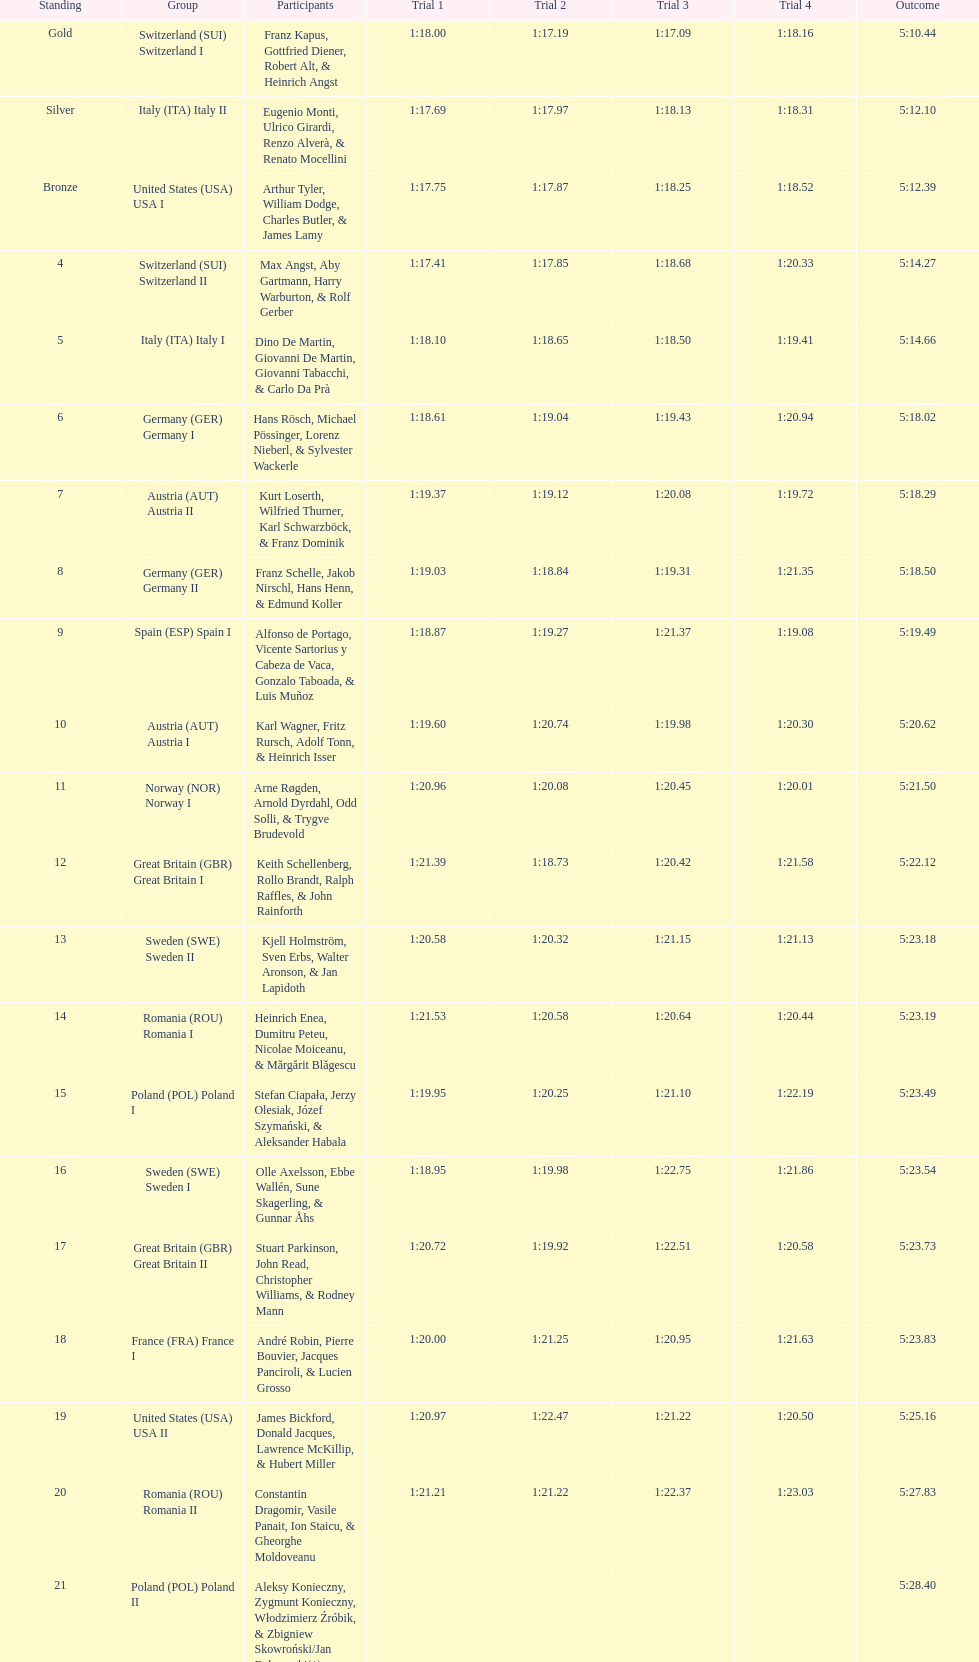Who is the previous team to italy (ita) italy ii? Switzerland (SUI) Switzerland I. 